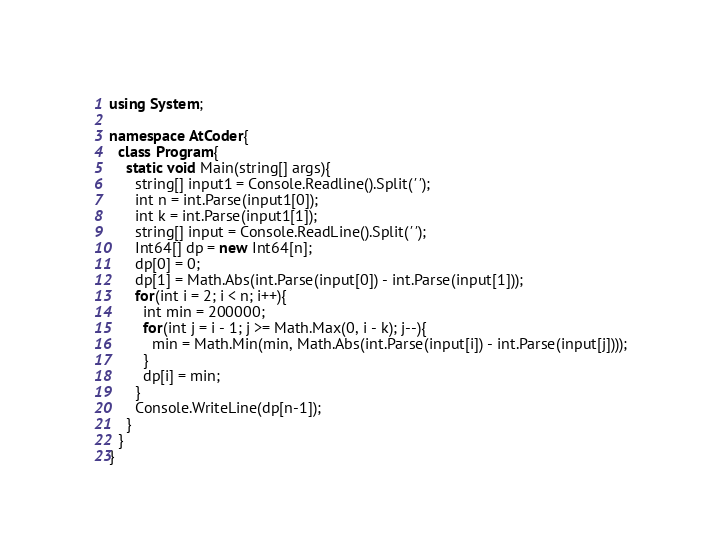<code> <loc_0><loc_0><loc_500><loc_500><_C#_>using System;

namespace AtCoder{
  class Program{
    static void Main(string[] args){
      string[] input1 = Console.Readline().Split(' ');
      int n = int.Parse(input1[0]);
      int k = int.Parse(input1[1]);
      string[] input = Console.ReadLine().Split(' ');
      Int64[] dp = new Int64[n];
      dp[0] = 0;
      dp[1] = Math.Abs(int.Parse(input[0]) - int.Parse(input[1]));
      for(int i = 2; i < n; i++){
        int min = 200000;
        for(int j = i - 1; j >= Math.Max(0, i - k); j--){
          min = Math.Min(min, Math.Abs(int.Parse(input[i]) - int.Parse(input[j])));
        }
        dp[i] = min;
      }
      Console.WriteLine(dp[n-1]);
    }
  }
}
</code> 